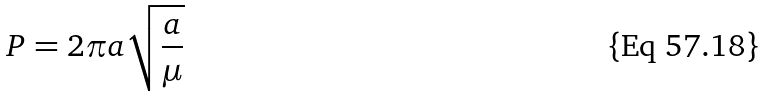<formula> <loc_0><loc_0><loc_500><loc_500>P = 2 \pi a \sqrt { \frac { a } { \mu } }</formula> 